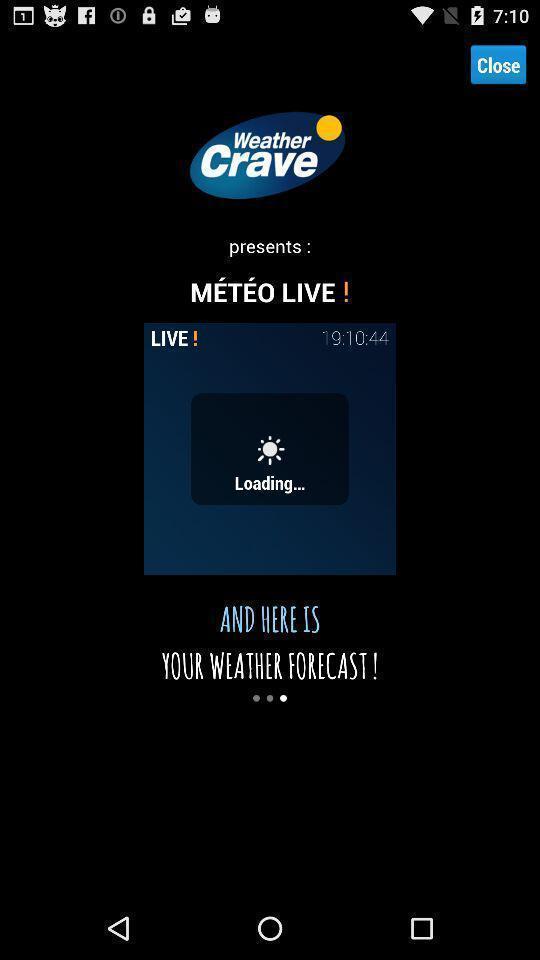Summarize the main components in this picture. Screen displaying page of an weather forecast application. 